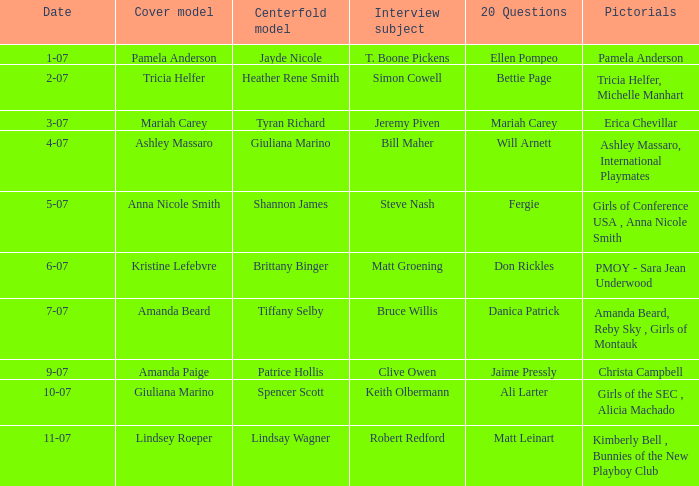Who was the cover model when the issue's pictorials was pmoy - sara jean underwood? Kristine Lefebvre. 